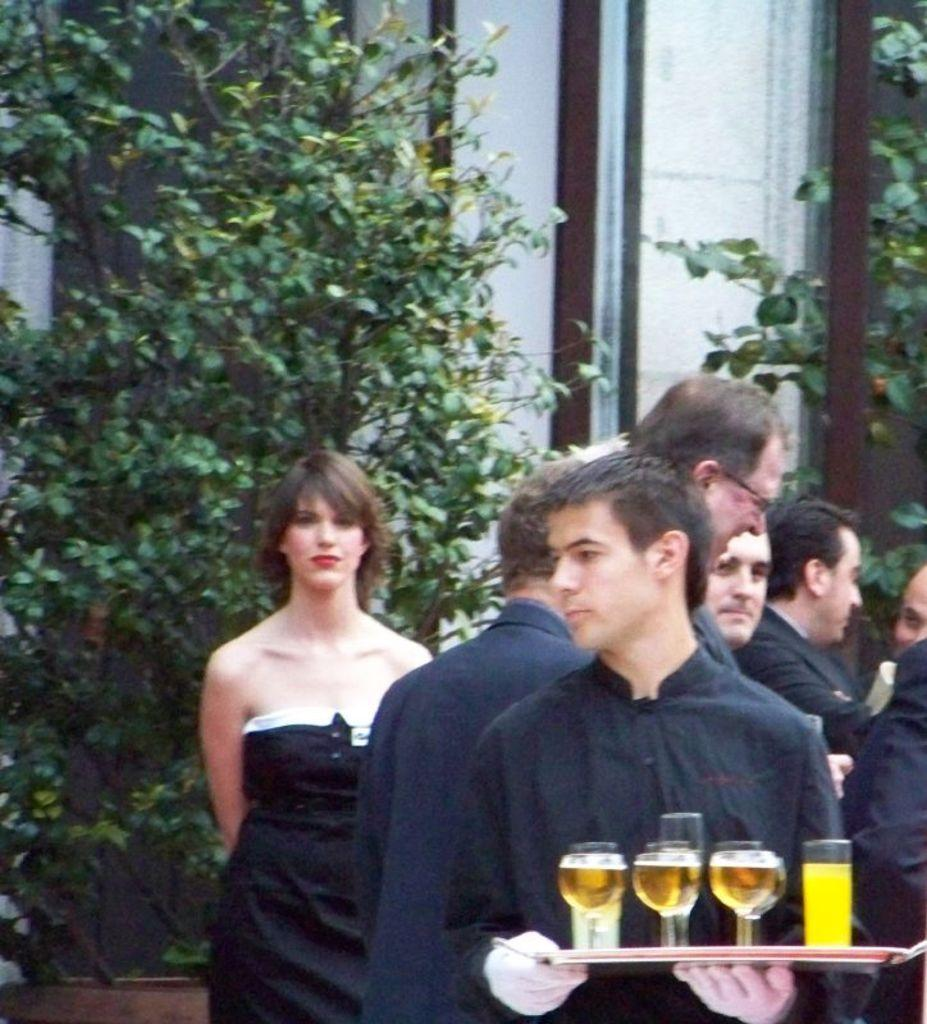How many people are in the image? There are people standing in the image. What is one person holding in the image? One person is holding a glass tray. What can be seen in the distance behind the people? There are trees and buildings visible in the background. How many hens are visible in the image? There are no hens present in the image. What type of parent is standing next to the person holding the glass tray? There is no indication of any parent or family relationship in the image. 